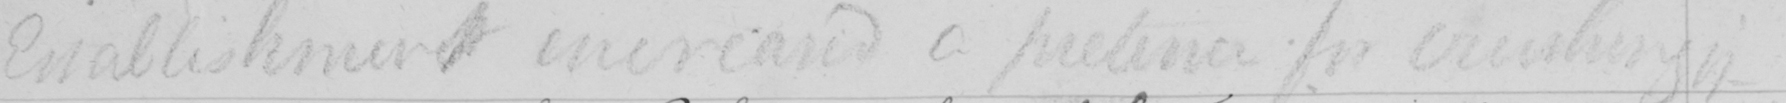Please transcribe the handwritten text in this image. Establishment increased on pretence of crushing it 